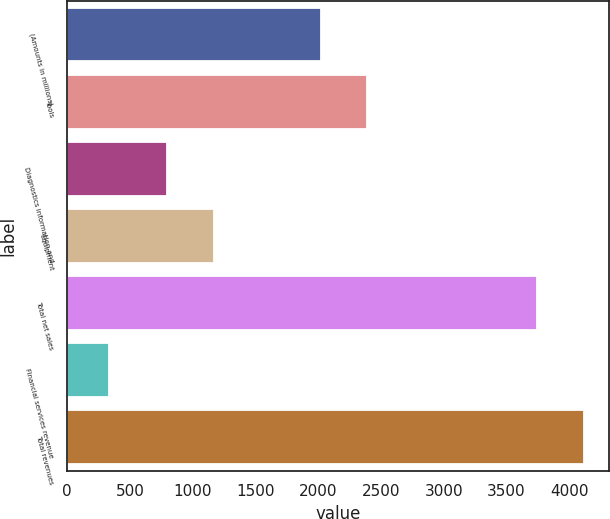Convert chart to OTSL. <chart><loc_0><loc_0><loc_500><loc_500><bar_chart><fcel>(Amounts in millions)<fcel>Tools<fcel>Diagnostics information and<fcel>Equipment<fcel>Total net sales<fcel>Financial services revenue<fcel>Total revenues<nl><fcel>2018<fcel>2392.07<fcel>797.9<fcel>1171.97<fcel>3740.7<fcel>329.7<fcel>4114.77<nl></chart> 